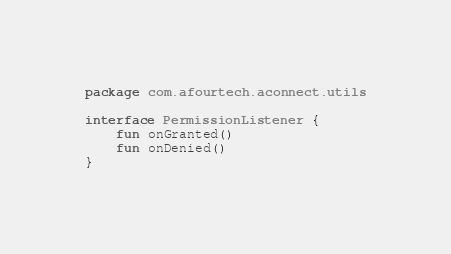<code> <loc_0><loc_0><loc_500><loc_500><_Kotlin_>package com.afourtech.aconnect.utils

interface PermissionListener {
    fun onGranted()
    fun onDenied()
}</code> 